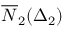<formula> <loc_0><loc_0><loc_500><loc_500>\overline { N } _ { 2 } ( \Delta _ { 2 } )</formula> 